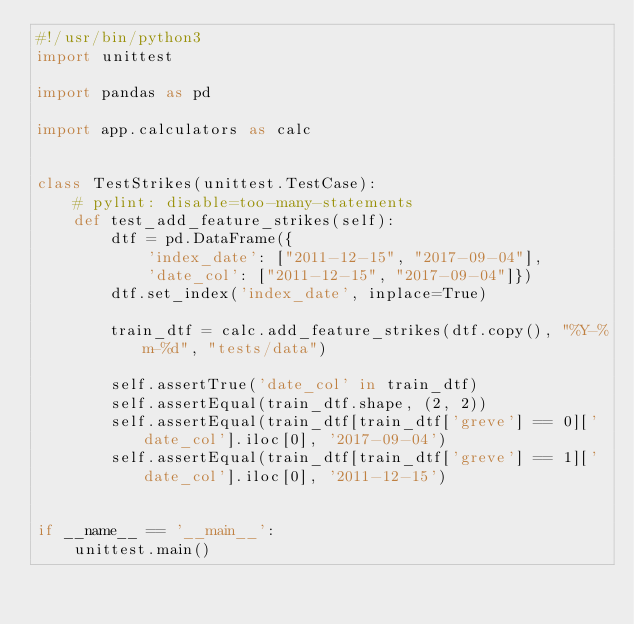Convert code to text. <code><loc_0><loc_0><loc_500><loc_500><_Python_>#!/usr/bin/python3
import unittest

import pandas as pd

import app.calculators as calc


class TestStrikes(unittest.TestCase):
    # pylint: disable=too-many-statements
    def test_add_feature_strikes(self):
        dtf = pd.DataFrame({
            'index_date': ["2011-12-15", "2017-09-04"],
            'date_col': ["2011-12-15", "2017-09-04"]})
        dtf.set_index('index_date', inplace=True)

        train_dtf = calc.add_feature_strikes(dtf.copy(), "%Y-%m-%d", "tests/data")

        self.assertTrue('date_col' in train_dtf)
        self.assertEqual(train_dtf.shape, (2, 2))
        self.assertEqual(train_dtf[train_dtf['greve'] == 0]['date_col'].iloc[0], '2017-09-04')
        self.assertEqual(train_dtf[train_dtf['greve'] == 1]['date_col'].iloc[0], '2011-12-15')


if __name__ == '__main__':
    unittest.main()
</code> 